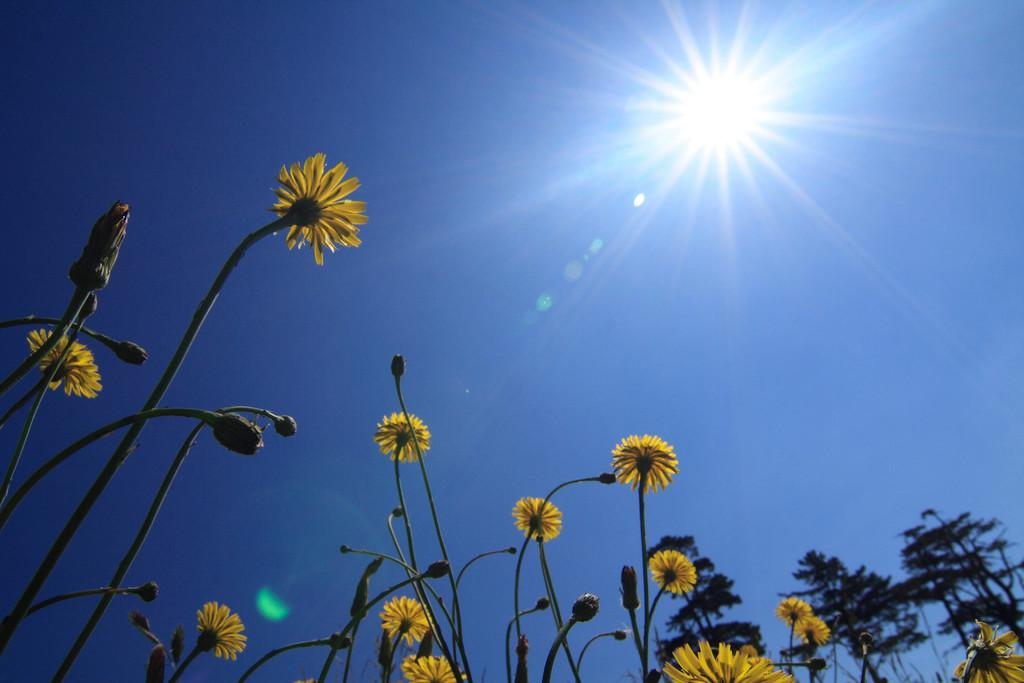What type of living organisms can be seen in the image? Plants can be seen in the image. What color are the flowers on the plants? The flowers on the plants are yellow. What stage of growth can be observed on the plants? The plants have buds, indicating they are in the process of blooming. What is visible at the top of the image? The sky is visible at the top of the image. Can the sun be seen in the image? Yes, the sun is observable in the sky. What type of muscle can be seen flexing in the image? There is no muscle visible in the image; it features plants with yellow flowers and buds. Is there a bike present in the image? No, there is no bike present in the image. 